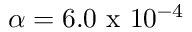<formula> <loc_0><loc_0><loc_500><loc_500>\alpha = 6 . 0 x 1 0 ^ { - 4 }</formula> 